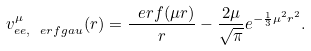<formula> <loc_0><loc_0><loc_500><loc_500>v _ { e e , \ e r f g a u } ^ { \mu } ( r ) = \frac { \ e r f ( \mu r ) } { r } - \frac { 2 \mu } { \sqrt { \pi } } e ^ { - \frac { 1 } { 3 } \mu ^ { 2 } r ^ { 2 } } .</formula> 